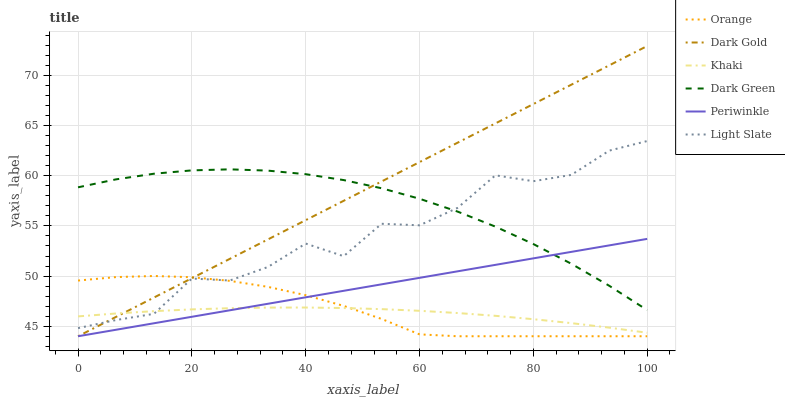Does Khaki have the minimum area under the curve?
Answer yes or no. Yes. Does Dark Gold have the maximum area under the curve?
Answer yes or no. Yes. Does Light Slate have the minimum area under the curve?
Answer yes or no. No. Does Light Slate have the maximum area under the curve?
Answer yes or no. No. Is Periwinkle the smoothest?
Answer yes or no. Yes. Is Light Slate the roughest?
Answer yes or no. Yes. Is Dark Gold the smoothest?
Answer yes or no. No. Is Dark Gold the roughest?
Answer yes or no. No. Does Dark Gold have the lowest value?
Answer yes or no. Yes. Does Light Slate have the lowest value?
Answer yes or no. No. Does Dark Gold have the highest value?
Answer yes or no. Yes. Does Light Slate have the highest value?
Answer yes or no. No. Is Orange less than Dark Green?
Answer yes or no. Yes. Is Light Slate greater than Periwinkle?
Answer yes or no. Yes. Does Light Slate intersect Khaki?
Answer yes or no. Yes. Is Light Slate less than Khaki?
Answer yes or no. No. Is Light Slate greater than Khaki?
Answer yes or no. No. Does Orange intersect Dark Green?
Answer yes or no. No. 